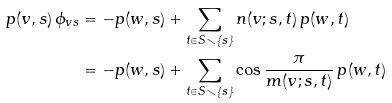<formula> <loc_0><loc_0><loc_500><loc_500>p ( v , s ) \, \phi _ { v s } & = - p ( w , s ) + \sum _ { t \in S \smallsetminus \{ s \} } n ( v ; s , t ) \, p ( w , t ) \\ & = - p ( w , s ) + \sum _ { t \in S \smallsetminus \{ s \} } \cos \frac { \pi } { m ( v ; s , t ) } \, p ( w , t )</formula> 